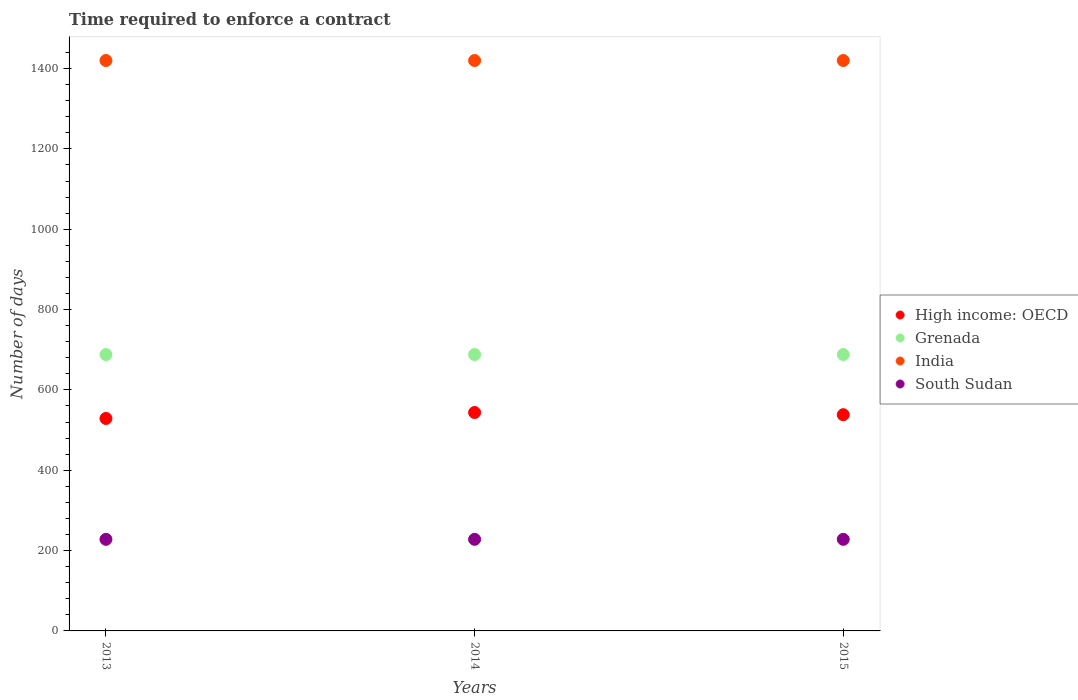How many different coloured dotlines are there?
Offer a very short reply. 4. Is the number of dotlines equal to the number of legend labels?
Keep it short and to the point. Yes. What is the number of days required to enforce a contract in India in 2013?
Ensure brevity in your answer.  1420. Across all years, what is the maximum number of days required to enforce a contract in India?
Provide a succinct answer. 1420. Across all years, what is the minimum number of days required to enforce a contract in High income: OECD?
Your response must be concise. 528.91. What is the total number of days required to enforce a contract in High income: OECD in the graph?
Make the answer very short. 1610.94. What is the difference between the number of days required to enforce a contract in India in 2013 and the number of days required to enforce a contract in High income: OECD in 2014?
Your answer should be very brief. 876.25. What is the average number of days required to enforce a contract in High income: OECD per year?
Give a very brief answer. 536.98. In the year 2015, what is the difference between the number of days required to enforce a contract in High income: OECD and number of days required to enforce a contract in South Sudan?
Provide a short and direct response. 310.28. Is the difference between the number of days required to enforce a contract in High income: OECD in 2014 and 2015 greater than the difference between the number of days required to enforce a contract in South Sudan in 2014 and 2015?
Your response must be concise. Yes. What is the difference between the highest and the second highest number of days required to enforce a contract in South Sudan?
Give a very brief answer. 0. What is the difference between the highest and the lowest number of days required to enforce a contract in India?
Your answer should be compact. 0. Is it the case that in every year, the sum of the number of days required to enforce a contract in High income: OECD and number of days required to enforce a contract in India  is greater than the sum of number of days required to enforce a contract in Grenada and number of days required to enforce a contract in South Sudan?
Ensure brevity in your answer.  Yes. Is it the case that in every year, the sum of the number of days required to enforce a contract in High income: OECD and number of days required to enforce a contract in India  is greater than the number of days required to enforce a contract in Grenada?
Make the answer very short. Yes. Is the number of days required to enforce a contract in Grenada strictly greater than the number of days required to enforce a contract in South Sudan over the years?
Make the answer very short. Yes. How many dotlines are there?
Your answer should be very brief. 4. How many years are there in the graph?
Your response must be concise. 3. What is the difference between two consecutive major ticks on the Y-axis?
Your response must be concise. 200. Are the values on the major ticks of Y-axis written in scientific E-notation?
Ensure brevity in your answer.  No. Does the graph contain any zero values?
Keep it short and to the point. No. Does the graph contain grids?
Ensure brevity in your answer.  No. Where does the legend appear in the graph?
Offer a terse response. Center right. What is the title of the graph?
Your answer should be compact. Time required to enforce a contract. Does "Zimbabwe" appear as one of the legend labels in the graph?
Make the answer very short. No. What is the label or title of the X-axis?
Ensure brevity in your answer.  Years. What is the label or title of the Y-axis?
Keep it short and to the point. Number of days. What is the Number of days in High income: OECD in 2013?
Ensure brevity in your answer.  528.91. What is the Number of days in Grenada in 2013?
Offer a terse response. 688. What is the Number of days in India in 2013?
Offer a terse response. 1420. What is the Number of days in South Sudan in 2013?
Your answer should be compact. 228. What is the Number of days in High income: OECD in 2014?
Make the answer very short. 543.75. What is the Number of days of Grenada in 2014?
Your answer should be compact. 688. What is the Number of days of India in 2014?
Ensure brevity in your answer.  1420. What is the Number of days in South Sudan in 2014?
Make the answer very short. 228. What is the Number of days of High income: OECD in 2015?
Provide a succinct answer. 538.28. What is the Number of days in Grenada in 2015?
Provide a succinct answer. 688. What is the Number of days in India in 2015?
Offer a very short reply. 1420. What is the Number of days of South Sudan in 2015?
Your response must be concise. 228. Across all years, what is the maximum Number of days in High income: OECD?
Make the answer very short. 543.75. Across all years, what is the maximum Number of days in Grenada?
Offer a terse response. 688. Across all years, what is the maximum Number of days in India?
Provide a short and direct response. 1420. Across all years, what is the maximum Number of days of South Sudan?
Offer a terse response. 228. Across all years, what is the minimum Number of days of High income: OECD?
Ensure brevity in your answer.  528.91. Across all years, what is the minimum Number of days in Grenada?
Your response must be concise. 688. Across all years, what is the minimum Number of days of India?
Provide a succinct answer. 1420. Across all years, what is the minimum Number of days in South Sudan?
Make the answer very short. 228. What is the total Number of days of High income: OECD in the graph?
Offer a terse response. 1610.94. What is the total Number of days in Grenada in the graph?
Make the answer very short. 2064. What is the total Number of days in India in the graph?
Your response must be concise. 4260. What is the total Number of days in South Sudan in the graph?
Offer a terse response. 684. What is the difference between the Number of days of High income: OECD in 2013 and that in 2014?
Your response must be concise. -14.84. What is the difference between the Number of days of South Sudan in 2013 and that in 2014?
Your answer should be compact. 0. What is the difference between the Number of days in High income: OECD in 2013 and that in 2015?
Ensure brevity in your answer.  -9.38. What is the difference between the Number of days of High income: OECD in 2014 and that in 2015?
Keep it short and to the point. 5.47. What is the difference between the Number of days of Grenada in 2014 and that in 2015?
Offer a very short reply. 0. What is the difference between the Number of days of India in 2014 and that in 2015?
Provide a short and direct response. 0. What is the difference between the Number of days in High income: OECD in 2013 and the Number of days in Grenada in 2014?
Keep it short and to the point. -159.09. What is the difference between the Number of days in High income: OECD in 2013 and the Number of days in India in 2014?
Your answer should be very brief. -891.09. What is the difference between the Number of days of High income: OECD in 2013 and the Number of days of South Sudan in 2014?
Your answer should be very brief. 300.91. What is the difference between the Number of days of Grenada in 2013 and the Number of days of India in 2014?
Make the answer very short. -732. What is the difference between the Number of days in Grenada in 2013 and the Number of days in South Sudan in 2014?
Ensure brevity in your answer.  460. What is the difference between the Number of days in India in 2013 and the Number of days in South Sudan in 2014?
Give a very brief answer. 1192. What is the difference between the Number of days of High income: OECD in 2013 and the Number of days of Grenada in 2015?
Provide a short and direct response. -159.09. What is the difference between the Number of days in High income: OECD in 2013 and the Number of days in India in 2015?
Your response must be concise. -891.09. What is the difference between the Number of days of High income: OECD in 2013 and the Number of days of South Sudan in 2015?
Ensure brevity in your answer.  300.91. What is the difference between the Number of days in Grenada in 2013 and the Number of days in India in 2015?
Ensure brevity in your answer.  -732. What is the difference between the Number of days in Grenada in 2013 and the Number of days in South Sudan in 2015?
Offer a terse response. 460. What is the difference between the Number of days of India in 2013 and the Number of days of South Sudan in 2015?
Keep it short and to the point. 1192. What is the difference between the Number of days in High income: OECD in 2014 and the Number of days in Grenada in 2015?
Ensure brevity in your answer.  -144.25. What is the difference between the Number of days of High income: OECD in 2014 and the Number of days of India in 2015?
Offer a terse response. -876.25. What is the difference between the Number of days in High income: OECD in 2014 and the Number of days in South Sudan in 2015?
Keep it short and to the point. 315.75. What is the difference between the Number of days of Grenada in 2014 and the Number of days of India in 2015?
Provide a short and direct response. -732. What is the difference between the Number of days of Grenada in 2014 and the Number of days of South Sudan in 2015?
Your response must be concise. 460. What is the difference between the Number of days of India in 2014 and the Number of days of South Sudan in 2015?
Give a very brief answer. 1192. What is the average Number of days in High income: OECD per year?
Provide a short and direct response. 536.98. What is the average Number of days of Grenada per year?
Offer a very short reply. 688. What is the average Number of days of India per year?
Give a very brief answer. 1420. What is the average Number of days of South Sudan per year?
Keep it short and to the point. 228. In the year 2013, what is the difference between the Number of days of High income: OECD and Number of days of Grenada?
Keep it short and to the point. -159.09. In the year 2013, what is the difference between the Number of days in High income: OECD and Number of days in India?
Your response must be concise. -891.09. In the year 2013, what is the difference between the Number of days in High income: OECD and Number of days in South Sudan?
Your response must be concise. 300.91. In the year 2013, what is the difference between the Number of days in Grenada and Number of days in India?
Offer a terse response. -732. In the year 2013, what is the difference between the Number of days of Grenada and Number of days of South Sudan?
Keep it short and to the point. 460. In the year 2013, what is the difference between the Number of days in India and Number of days in South Sudan?
Ensure brevity in your answer.  1192. In the year 2014, what is the difference between the Number of days in High income: OECD and Number of days in Grenada?
Make the answer very short. -144.25. In the year 2014, what is the difference between the Number of days in High income: OECD and Number of days in India?
Your response must be concise. -876.25. In the year 2014, what is the difference between the Number of days in High income: OECD and Number of days in South Sudan?
Give a very brief answer. 315.75. In the year 2014, what is the difference between the Number of days in Grenada and Number of days in India?
Give a very brief answer. -732. In the year 2014, what is the difference between the Number of days of Grenada and Number of days of South Sudan?
Offer a terse response. 460. In the year 2014, what is the difference between the Number of days in India and Number of days in South Sudan?
Give a very brief answer. 1192. In the year 2015, what is the difference between the Number of days of High income: OECD and Number of days of Grenada?
Your answer should be compact. -149.72. In the year 2015, what is the difference between the Number of days in High income: OECD and Number of days in India?
Provide a succinct answer. -881.72. In the year 2015, what is the difference between the Number of days of High income: OECD and Number of days of South Sudan?
Provide a short and direct response. 310.28. In the year 2015, what is the difference between the Number of days of Grenada and Number of days of India?
Give a very brief answer. -732. In the year 2015, what is the difference between the Number of days in Grenada and Number of days in South Sudan?
Ensure brevity in your answer.  460. In the year 2015, what is the difference between the Number of days of India and Number of days of South Sudan?
Ensure brevity in your answer.  1192. What is the ratio of the Number of days of High income: OECD in 2013 to that in 2014?
Ensure brevity in your answer.  0.97. What is the ratio of the Number of days in Grenada in 2013 to that in 2014?
Provide a succinct answer. 1. What is the ratio of the Number of days in High income: OECD in 2013 to that in 2015?
Your answer should be compact. 0.98. What is the ratio of the Number of days of Grenada in 2013 to that in 2015?
Your response must be concise. 1. What is the ratio of the Number of days in India in 2013 to that in 2015?
Keep it short and to the point. 1. What is the ratio of the Number of days in High income: OECD in 2014 to that in 2015?
Provide a succinct answer. 1.01. What is the ratio of the Number of days of Grenada in 2014 to that in 2015?
Keep it short and to the point. 1. What is the ratio of the Number of days of India in 2014 to that in 2015?
Make the answer very short. 1. What is the difference between the highest and the second highest Number of days in High income: OECD?
Your response must be concise. 5.47. What is the difference between the highest and the second highest Number of days in Grenada?
Provide a succinct answer. 0. What is the difference between the highest and the second highest Number of days of South Sudan?
Keep it short and to the point. 0. What is the difference between the highest and the lowest Number of days of High income: OECD?
Keep it short and to the point. 14.84. 